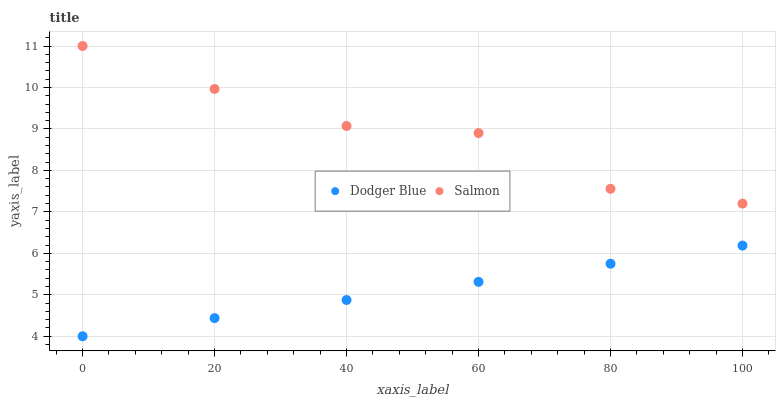Does Dodger Blue have the minimum area under the curve?
Answer yes or no. Yes. Does Salmon have the maximum area under the curve?
Answer yes or no. Yes. Does Dodger Blue have the maximum area under the curve?
Answer yes or no. No. Is Dodger Blue the smoothest?
Answer yes or no. Yes. Is Salmon the roughest?
Answer yes or no. Yes. Is Dodger Blue the roughest?
Answer yes or no. No. Does Dodger Blue have the lowest value?
Answer yes or no. Yes. Does Salmon have the highest value?
Answer yes or no. Yes. Does Dodger Blue have the highest value?
Answer yes or no. No. Is Dodger Blue less than Salmon?
Answer yes or no. Yes. Is Salmon greater than Dodger Blue?
Answer yes or no. Yes. Does Dodger Blue intersect Salmon?
Answer yes or no. No. 